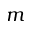<formula> <loc_0><loc_0><loc_500><loc_500>m</formula> 